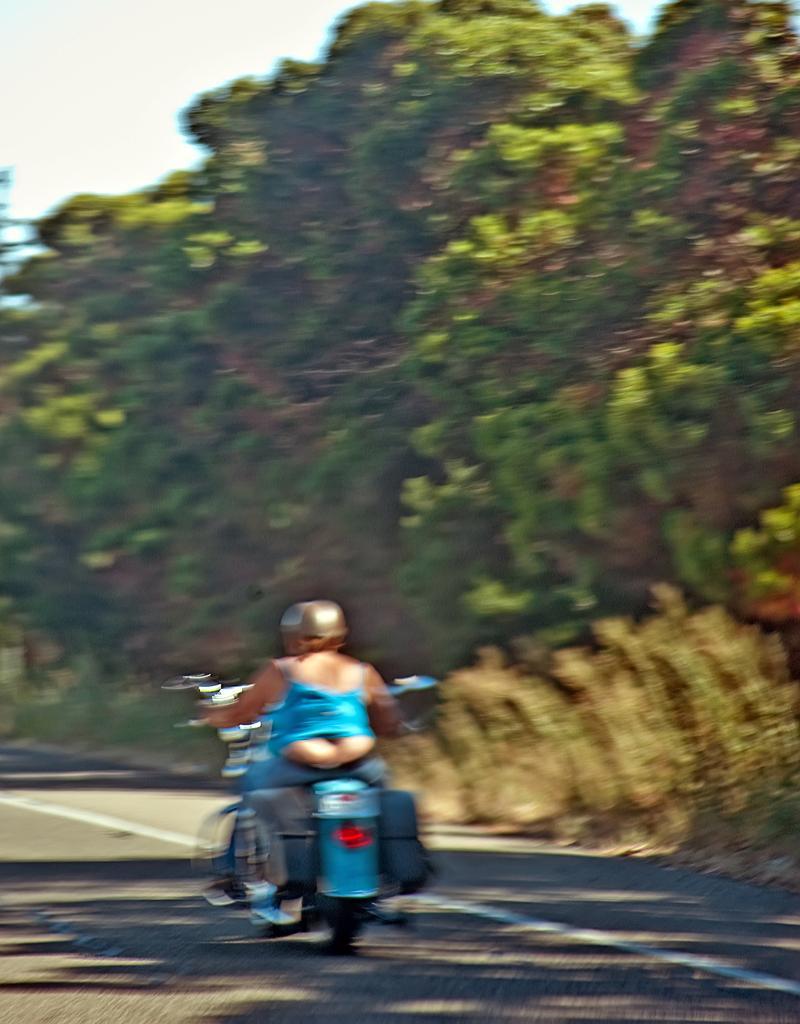Could you give a brief overview of what you see in this image? In this image we can see a person riding a motorcycle on the road, on the right side there are some trees and in the background we can see the sky. 